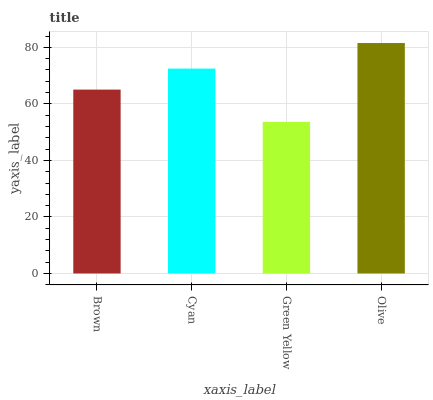Is Green Yellow the minimum?
Answer yes or no. Yes. Is Olive the maximum?
Answer yes or no. Yes. Is Cyan the minimum?
Answer yes or no. No. Is Cyan the maximum?
Answer yes or no. No. Is Cyan greater than Brown?
Answer yes or no. Yes. Is Brown less than Cyan?
Answer yes or no. Yes. Is Brown greater than Cyan?
Answer yes or no. No. Is Cyan less than Brown?
Answer yes or no. No. Is Cyan the high median?
Answer yes or no. Yes. Is Brown the low median?
Answer yes or no. Yes. Is Olive the high median?
Answer yes or no. No. Is Cyan the low median?
Answer yes or no. No. 